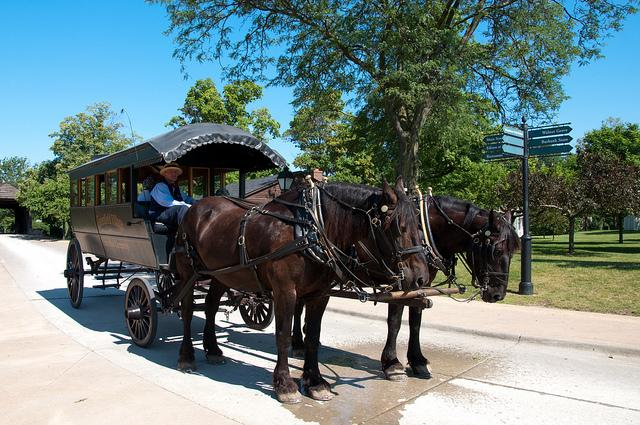What is the green item near the horses? tree 